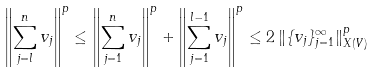<formula> <loc_0><loc_0><loc_500><loc_500>\left \| \sum _ { j = l } ^ { n } v _ { j } \right \| ^ { p } \leq \left \| \sum _ { j = 1 } ^ { n } v _ { j } \right \| ^ { p } + \left \| \sum _ { j = 1 } ^ { l - 1 } v _ { j } \right \| ^ { p } \leq 2 \, \| \{ v _ { j } \} _ { j = 1 } ^ { \infty } \| _ { X ( V ) } ^ { p }</formula> 